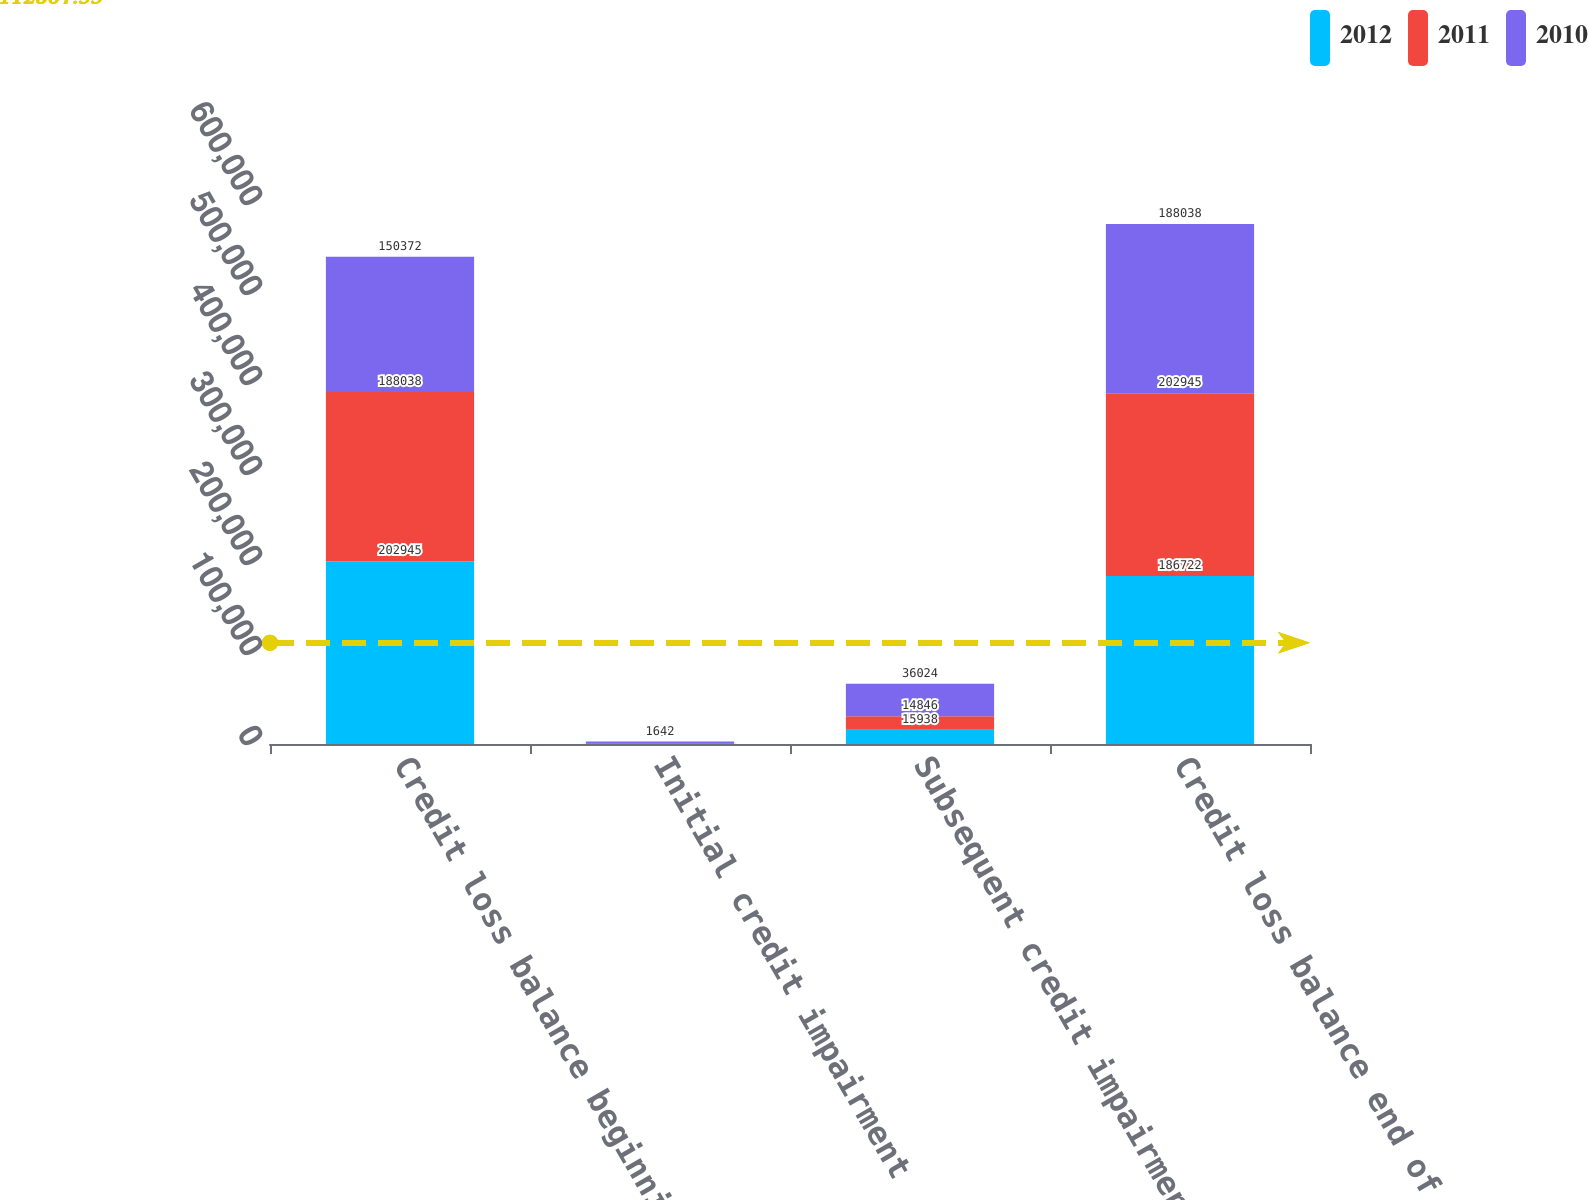<chart> <loc_0><loc_0><loc_500><loc_500><stacked_bar_chart><ecel><fcel>Credit loss balance beginning<fcel>Initial credit impairment<fcel>Subsequent credit impairment<fcel>Credit loss balance end of<nl><fcel>2012<fcel>202945<fcel>987<fcel>15938<fcel>186722<nl><fcel>2011<fcel>188038<fcel>61<fcel>14846<fcel>202945<nl><fcel>2010<fcel>150372<fcel>1642<fcel>36024<fcel>188038<nl></chart> 